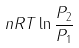Convert formula to latex. <formula><loc_0><loc_0><loc_500><loc_500>n R T \ln \frac { P _ { 2 } } { P _ { 1 } }</formula> 